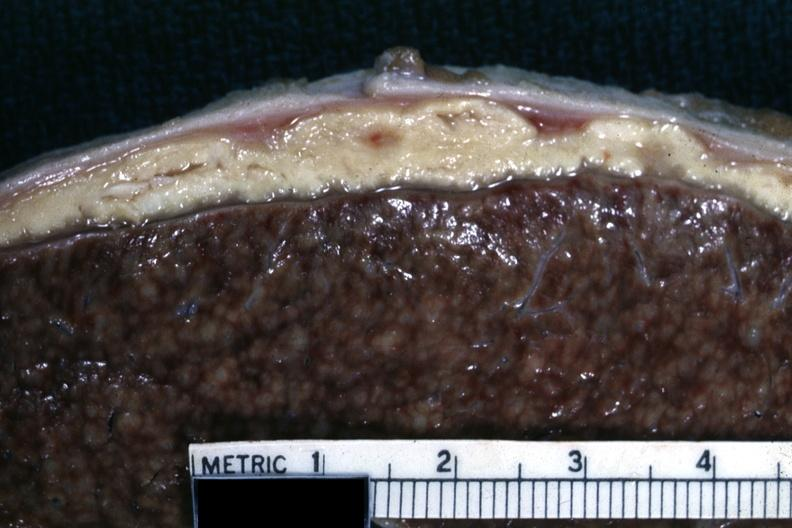s fat necrosis cold abscess material very typical?
Answer the question using a single word or phrase. No 